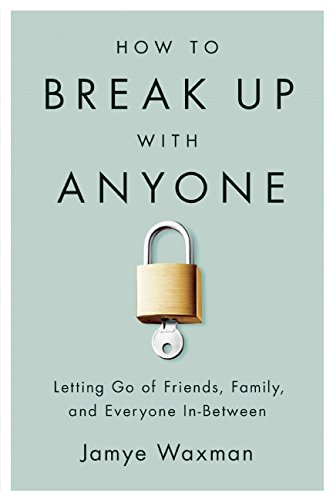Who wrote this book?
Answer the question using a single word or phrase. Jamye Waxman What is the title of this book? How to Break Up With Anyone: Letting Go of Friends, Family, and Everyone In-Between What is the genre of this book? Self-Help Is this a motivational book? Yes Is this a religious book? No 